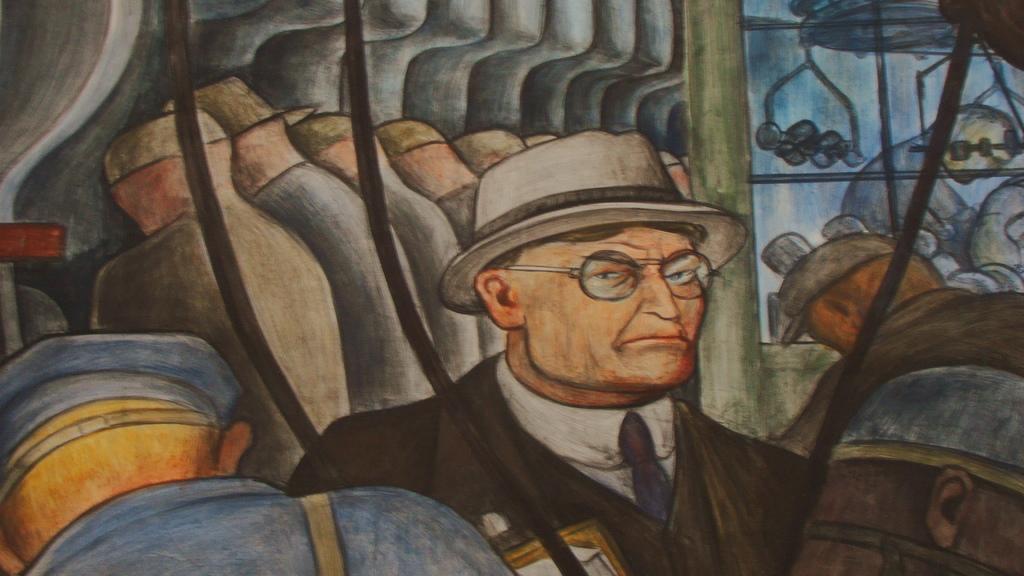How would you summarize this image in a sentence or two? In this image we can see a painting. In the painting there is a man from the forward and the other people from the backside. 